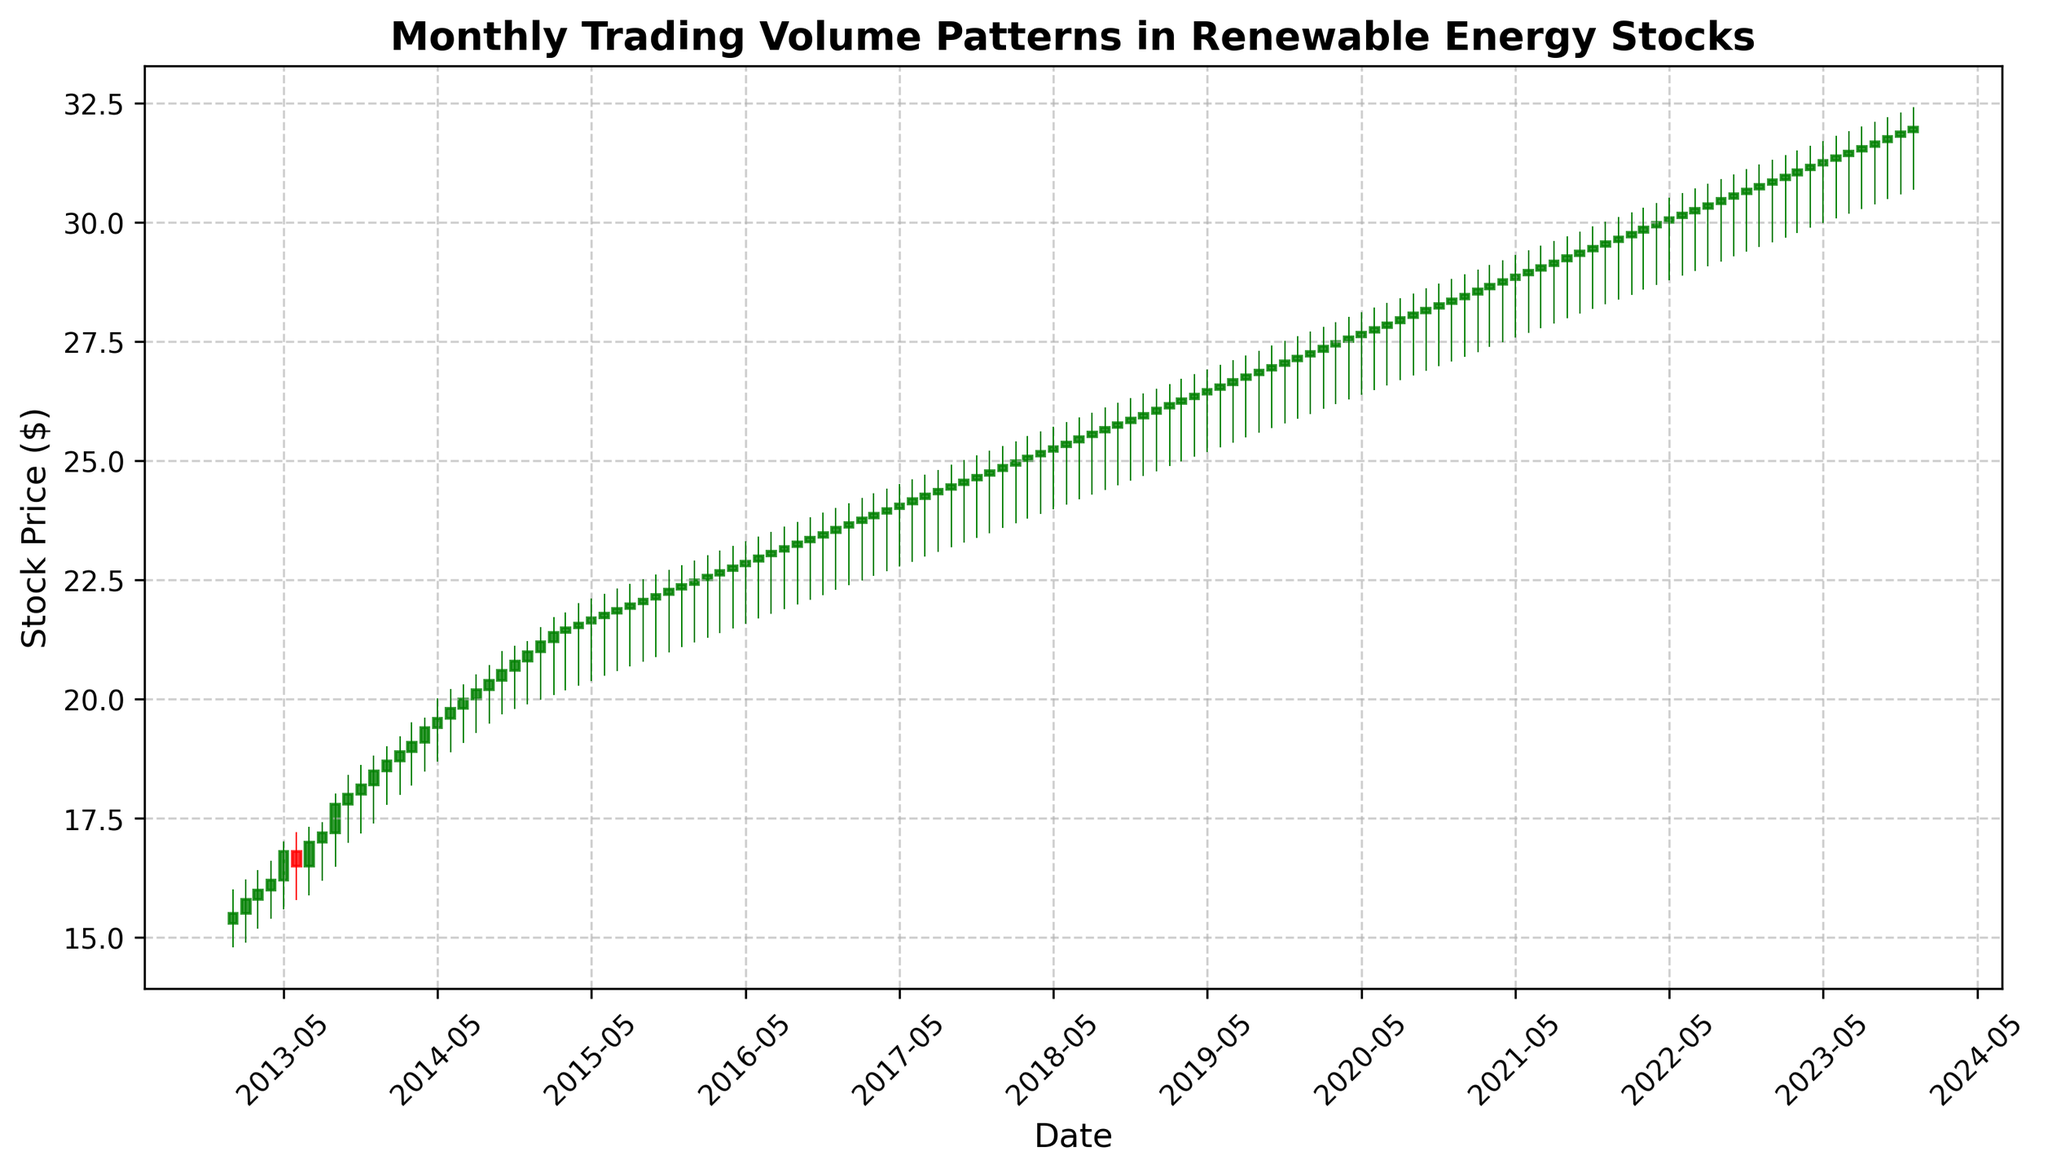What's the primary trend observed in the stock prices over the decade? The primary trend can be observed by examining the overall movement of stock prices from 2013 to 2023. The stock price started at around $15.30 in January 2013 and increased steadily over the years, reaching approximately $31.80 by December 2023, indicating a consistent upward trend.
Answer: Upward trend During which year did the stock show the highest trading volume? To determine this, look at the height of the volume bars along the x-axis of the chart for each year. The highest trading volume is observed in the year 2023.
Answer: 2023 Between which two consecutive years did the stock price see the highest growth? This can be determined by comparing the candle heights from year to year. The steepest increase in the height of the candles appears between 2017 and 2018, with the stock price rising from around $24.70 in December 2017 to about $25.90 by December 2018.
Answer: 2017-2018 Was there any year where the trading volume significantly decreased compared to the previous year? By examining the height of the volume bars, we notice that there's a consistent increase in trading volume with no significant decrease between consecutive years.
Answer: No What was the stock price range (difference between high and low) in January 2020? From the candlestick for January 2020, the high is $27.70 and the low is $26.00. Subtracting these gives the range: $27.70 - $26.00 = $1.70.
Answer: $1.70 Which year had the most stable stock prices (smallest difference between high and low)? To find this, compare the candlestick lengths (difference between high and low points) for each year. In 2013, the stock prices were most stable as the difference between high and low points was relatively small throughout the year.
Answer: 2013 From 2013 to 2023, which month typically shows a higher trading volume? Trading volumes can be compared by looking at the height of the volume bars across the years for each month. December frequently shows higher trading volumes compared to other months.
Answer: December What color identifies the candlesticks indicating a closing price higher than the opening price? The color of the candlesticks where the closing price is higher than the opening price is green.
Answer: Green How did the stock perform in 2016 in terms of price and volume? In 2016, the year started with a stock price of around $22.40 in January and ended at approximately $23.60 in December, showing an upward trend. The trading volume consistently increased from 2,450,000 in January to 2,725,000 in December.
Answer: Upward trend & increased volume Which month in 2022 had the highest stock price? Looking at the chart for 2022 and checking the top of the wicks (upper shadows) of the candlesticks, the highest stock price is in October 2022, reaching approximately $31.00.
Answer: October 